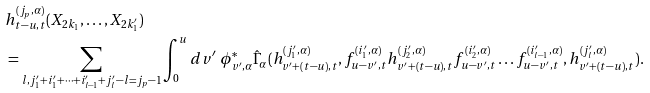<formula> <loc_0><loc_0><loc_500><loc_500>& h _ { t - u , t } ^ { ( j _ { p } , \alpha ) } ( X _ { 2 k _ { 1 } } , \dots , X _ { 2 k _ { 1 } ^ { \prime } } ) \\ & = \sum _ { l , j _ { 1 } ^ { \prime } + i _ { 1 } ^ { \prime } + \dots + i _ { l - 1 } ^ { \prime } + j _ { l } ^ { \prime } - l = j _ { p } - 1 } \int _ { 0 } ^ { u } d v ^ { \prime } \ \phi _ { v ^ { \prime } , \alpha } ^ { * } \hat { \Gamma } _ { \alpha } ( h _ { v ^ { \prime } + ( t - u ) , t } ^ { ( j _ { 1 } ^ { \prime } , \alpha ) } , f _ { u - v ^ { \prime } , t } ^ { ( i _ { 1 } ^ { \prime } , \alpha ) } h _ { v ^ { \prime } + ( t - u ) , t } ^ { ( j _ { 2 } ^ { \prime } , \alpha ) } f _ { u - v ^ { \prime } , t } ^ { ( i _ { 2 } ^ { \prime } , \alpha ) } \dots f _ { u - v ^ { \prime } , t } ^ { ( i _ { l - 1 } ^ { \prime } , \alpha ) } , h _ { v ^ { \prime } + ( t - u ) , t } ^ { ( j _ { l } ^ { \prime } , \alpha ) } ) .</formula> 